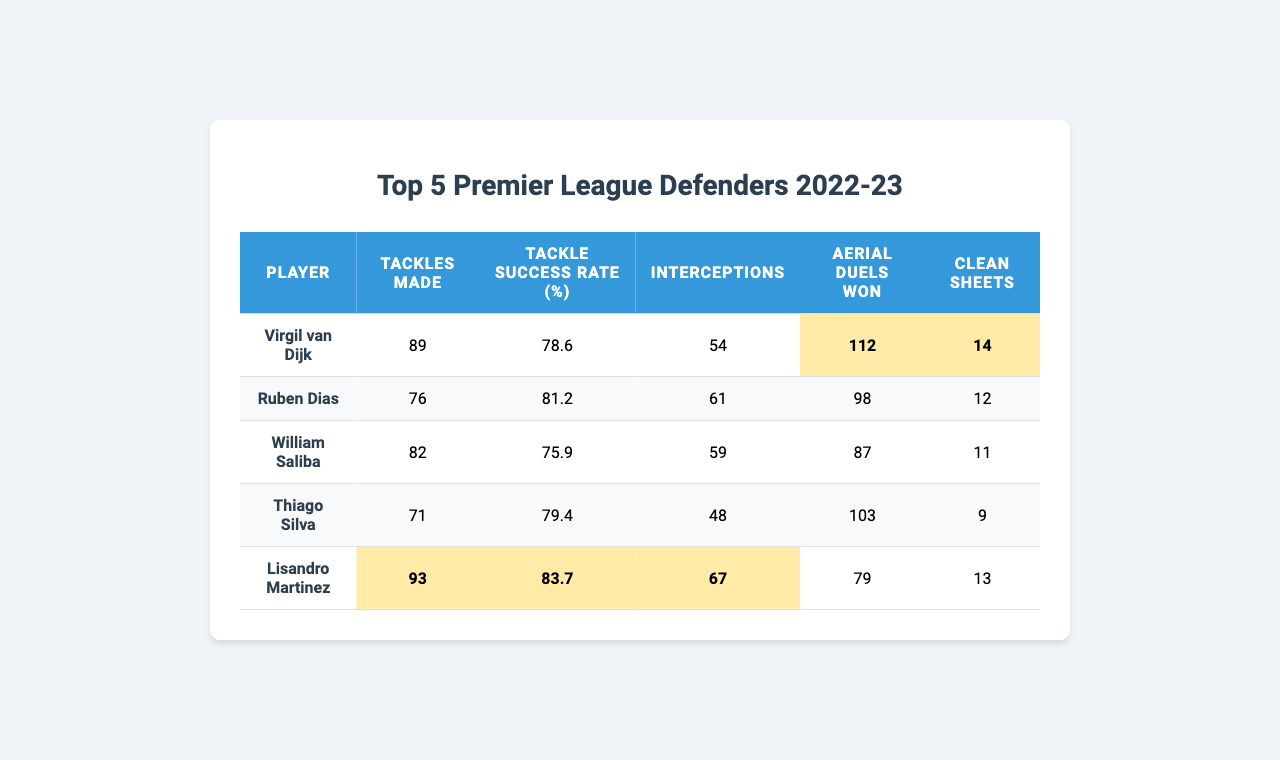What player made the most tackles? By looking at the "Tackles Made" column, Virgil van Dijk has the highest number with 89 tackles.
Answer: Virgil van Dijk What is Lisandro Martinez's tackle success rate? The "Tackle Success Rate (%)" column reveals that Lisandro Martinez has a success rate of 83.7%.
Answer: 83.7% How many interceptions did Thiago Silva make? The "Interceptions" column shows that Thiago Silva made 48 interceptions.
Answer: 48 Who had the highest number of aerial duels won? By checking the "Aerial Duels Won" column, it's clear that Virgil van Dijk won 112 aerial duels, the highest among all players.
Answer: Virgil van Dijk Did William Saliba achieve more clean sheets than Ruben Dias? Checking the "Clean Sheets" column, William Saliba has 11 clean sheets while Ruben Dias has 12, so Saliba did not achieve more.
Answer: No What is the average number of tackles made by these defenders? To find the average, sum the tackles made (89 + 76 + 82 + 71 + 93 = 411) and divide by the number of players (5). The average is 411/5 = 82.2.
Answer: 82.2 Which player has the lowest number of clean sheets? Looking at the "Clean Sheets" column, the data shows that Thiago Silva has the lowest with 9 clean sheets.
Answer: Thiago Silva What is the difference in interceptions between Lisandro Martinez and Ruben Dias? With Lisandro Martinez having 67 and Ruben Dias having 61 interceptions, the difference is 67 - 61 = 6.
Answer: 6 Which defender had both the highest number of tackles and clean sheets? The player with the highest tackles is Virgil van Dijk with 89 tackles, and he also has 14 clean sheets, making him the only defender to hold the top position in both categories.
Answer: Virgil van Dijk What percentage of tackles was successful for the player with the most tackles? Virgil van Dijk, who made the most tackles (89), had a tackle success rate of 78.6%. This is confirmed by reference to the "Tackle Success Rate (%)".
Answer: 78.6% 